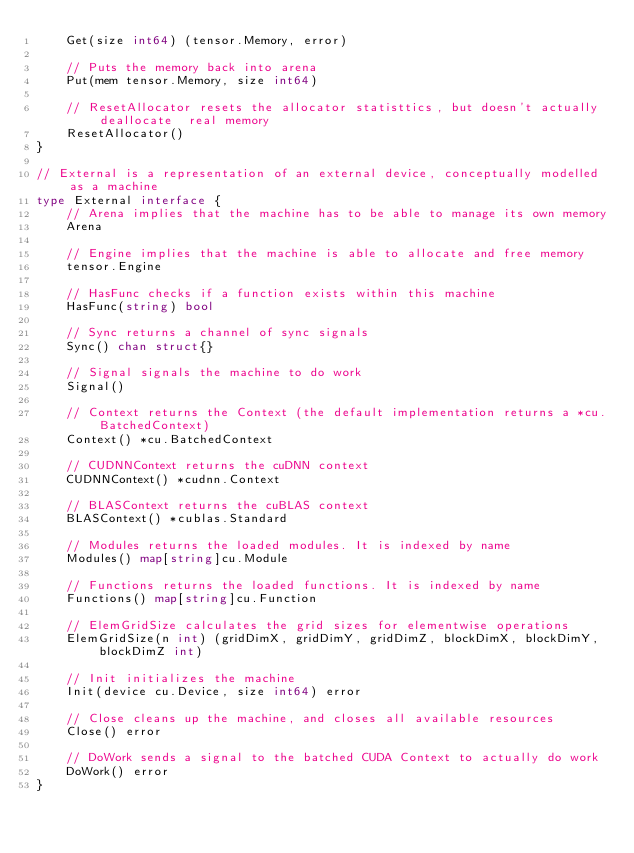Convert code to text. <code><loc_0><loc_0><loc_500><loc_500><_Go_>	Get(size int64) (tensor.Memory, error)

	// Puts the memory back into arena
	Put(mem tensor.Memory, size int64)

	// ResetAllocator resets the allocator statisttics, but doesn't actually deallocate  real memory
	ResetAllocator()
}

// External is a representation of an external device, conceptually modelled as a machine
type External interface {
	// Arena implies that the machine has to be able to manage its own memory
	Arena

	// Engine implies that the machine is able to allocate and free memory
	tensor.Engine

	// HasFunc checks if a function exists within this machine
	HasFunc(string) bool

	// Sync returns a channel of sync signals
	Sync() chan struct{}

	// Signal signals the machine to do work
	Signal()

	// Context returns the Context (the default implementation returns a *cu.BatchedContext)
	Context() *cu.BatchedContext

	// CUDNNContext returns the cuDNN context
	CUDNNContext() *cudnn.Context

	// BLASContext returns the cuBLAS context
	BLASContext() *cublas.Standard

	// Modules returns the loaded modules. It is indexed by name
	Modules() map[string]cu.Module

	// Functions returns the loaded functions. It is indexed by name
	Functions() map[string]cu.Function

	// ElemGridSize calculates the grid sizes for elementwise operations
	ElemGridSize(n int) (gridDimX, gridDimY, gridDimZ, blockDimX, blockDimY, blockDimZ int)

	// Init initializes the machine
	Init(device cu.Device, size int64) error

	// Close cleans up the machine, and closes all available resources
	Close() error

	// DoWork sends a signal to the batched CUDA Context to actually do work
	DoWork() error
}
</code> 